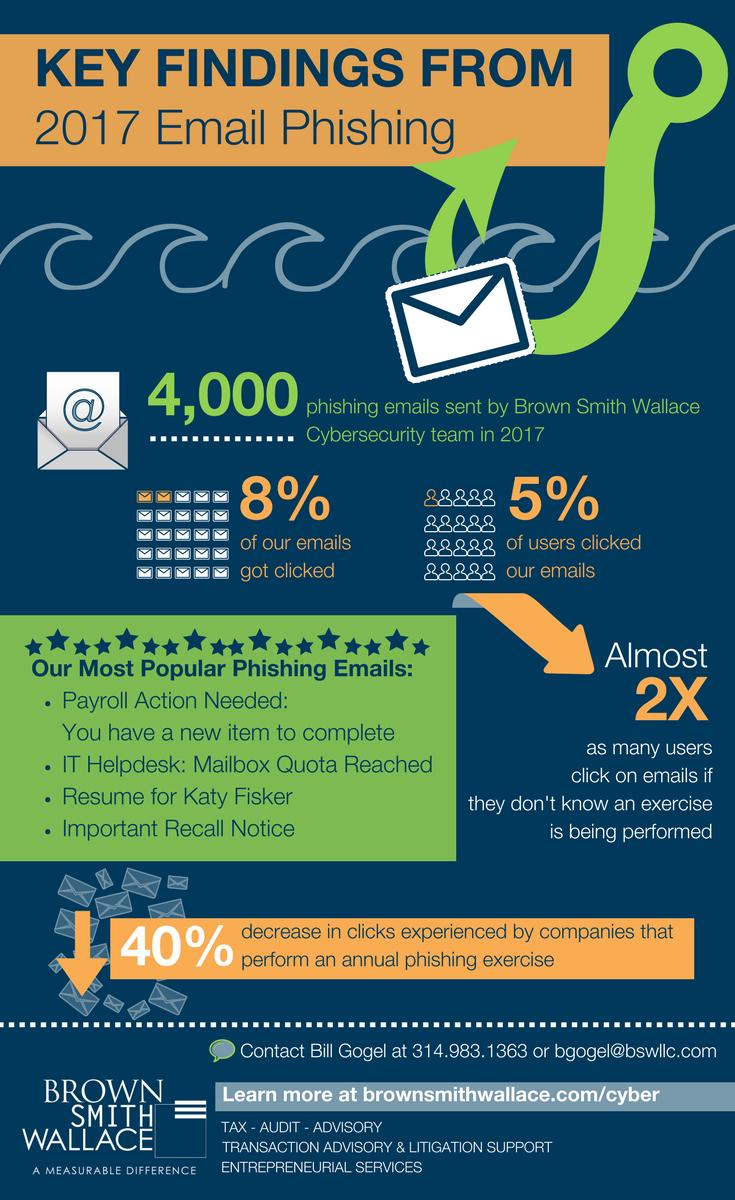Identify some key points in this picture. The fourth most prevalent phishing email is the one that contains an 'Important recall notice.' The third most popular phishing email is one that is designed to resemble a job application and is addressed to Katy Fiskar. 